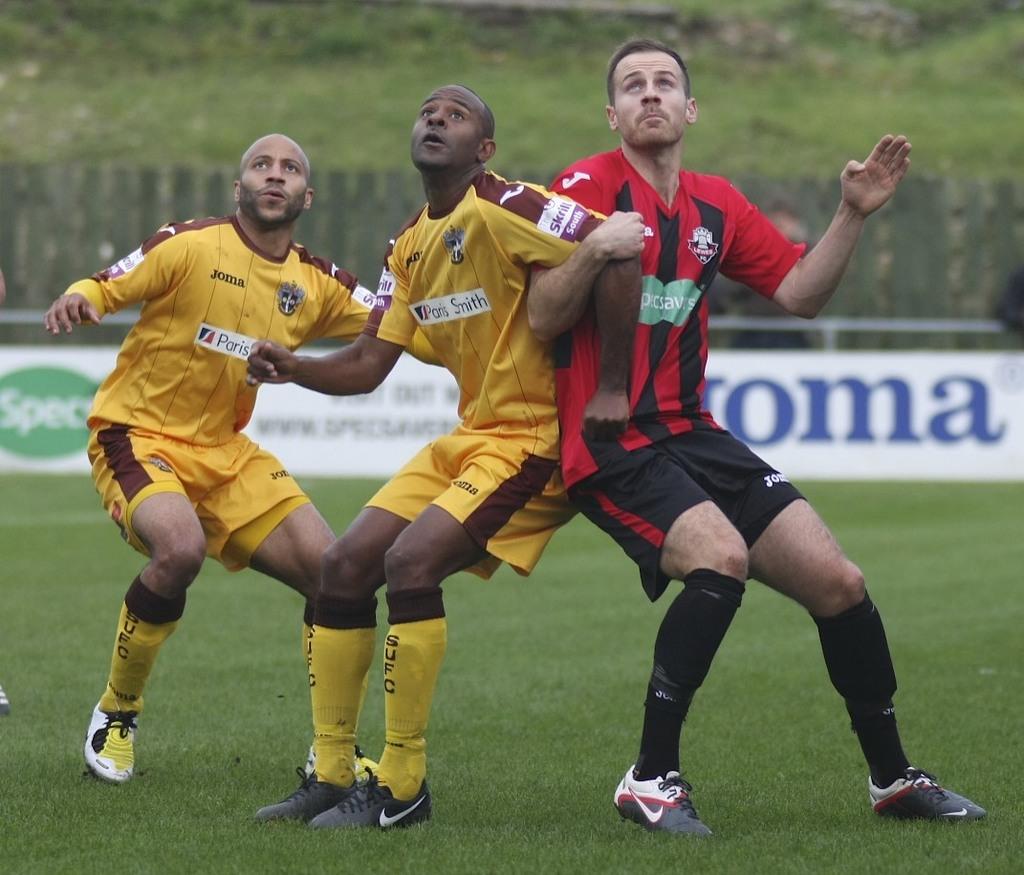What city is the stamp from?
Your answer should be compact. Unanswerable. What's the company that makes the mans yellow shirt?
Give a very brief answer. Joma. 